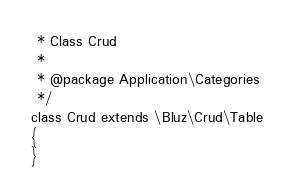Convert code to text. <code><loc_0><loc_0><loc_500><loc_500><_PHP_> * Class Crud
 *
 * @package Application\Categories
 */
class Crud extends \Bluz\Crud\Table
{
}
</code> 